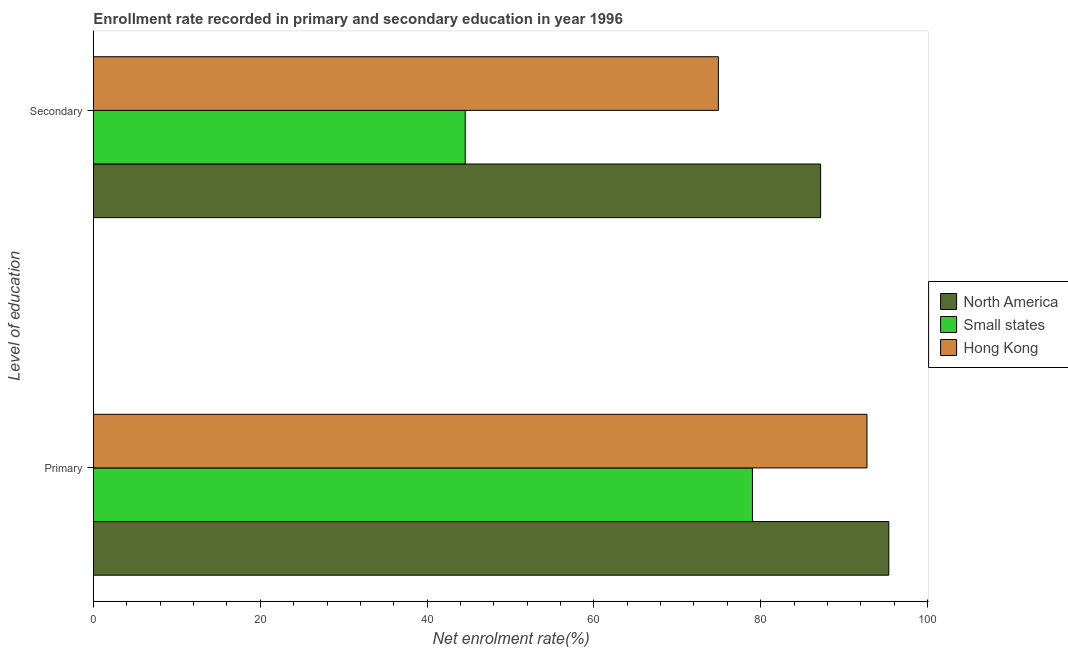How many groups of bars are there?
Your answer should be very brief. 2. Are the number of bars on each tick of the Y-axis equal?
Your response must be concise. Yes. How many bars are there on the 1st tick from the top?
Ensure brevity in your answer.  3. How many bars are there on the 2nd tick from the bottom?
Keep it short and to the point. 3. What is the label of the 1st group of bars from the top?
Keep it short and to the point. Secondary. What is the enrollment rate in secondary education in Hong Kong?
Your answer should be compact. 74.93. Across all countries, what is the maximum enrollment rate in primary education?
Your response must be concise. 95.36. Across all countries, what is the minimum enrollment rate in primary education?
Your response must be concise. 79.01. In which country was the enrollment rate in primary education minimum?
Keep it short and to the point. Small states. What is the total enrollment rate in secondary education in the graph?
Your response must be concise. 206.69. What is the difference between the enrollment rate in secondary education in Hong Kong and that in Small states?
Provide a short and direct response. 30.35. What is the difference between the enrollment rate in secondary education in Small states and the enrollment rate in primary education in North America?
Keep it short and to the point. -50.79. What is the average enrollment rate in primary education per country?
Offer a terse response. 89.04. What is the difference between the enrollment rate in secondary education and enrollment rate in primary education in Hong Kong?
Make the answer very short. -17.82. In how many countries, is the enrollment rate in primary education greater than 48 %?
Give a very brief answer. 3. What is the ratio of the enrollment rate in secondary education in Hong Kong to that in North America?
Keep it short and to the point. 0.86. In how many countries, is the enrollment rate in secondary education greater than the average enrollment rate in secondary education taken over all countries?
Ensure brevity in your answer.  2. What does the 2nd bar from the top in Secondary represents?
Make the answer very short. Small states. What does the 3rd bar from the bottom in Primary represents?
Your response must be concise. Hong Kong. How many bars are there?
Your answer should be very brief. 6. Are all the bars in the graph horizontal?
Ensure brevity in your answer.  Yes. What is the difference between two consecutive major ticks on the X-axis?
Ensure brevity in your answer.  20. Are the values on the major ticks of X-axis written in scientific E-notation?
Make the answer very short. No. Where does the legend appear in the graph?
Your response must be concise. Center right. What is the title of the graph?
Give a very brief answer. Enrollment rate recorded in primary and secondary education in year 1996. Does "Dominican Republic" appear as one of the legend labels in the graph?
Your answer should be compact. No. What is the label or title of the X-axis?
Provide a succinct answer. Net enrolment rate(%). What is the label or title of the Y-axis?
Your answer should be very brief. Level of education. What is the Net enrolment rate(%) of North America in Primary?
Provide a short and direct response. 95.36. What is the Net enrolment rate(%) in Small states in Primary?
Make the answer very short. 79.01. What is the Net enrolment rate(%) in Hong Kong in Primary?
Offer a terse response. 92.74. What is the Net enrolment rate(%) in North America in Secondary?
Ensure brevity in your answer.  87.19. What is the Net enrolment rate(%) of Small states in Secondary?
Offer a terse response. 44.57. What is the Net enrolment rate(%) of Hong Kong in Secondary?
Offer a terse response. 74.93. Across all Level of education, what is the maximum Net enrolment rate(%) of North America?
Your answer should be compact. 95.36. Across all Level of education, what is the maximum Net enrolment rate(%) in Small states?
Your answer should be very brief. 79.01. Across all Level of education, what is the maximum Net enrolment rate(%) of Hong Kong?
Ensure brevity in your answer.  92.74. Across all Level of education, what is the minimum Net enrolment rate(%) in North America?
Offer a very short reply. 87.19. Across all Level of education, what is the minimum Net enrolment rate(%) of Small states?
Your answer should be compact. 44.57. Across all Level of education, what is the minimum Net enrolment rate(%) of Hong Kong?
Your answer should be compact. 74.93. What is the total Net enrolment rate(%) in North America in the graph?
Offer a terse response. 182.55. What is the total Net enrolment rate(%) in Small states in the graph?
Ensure brevity in your answer.  123.58. What is the total Net enrolment rate(%) of Hong Kong in the graph?
Keep it short and to the point. 167.67. What is the difference between the Net enrolment rate(%) of North America in Primary and that in Secondary?
Your answer should be compact. 8.18. What is the difference between the Net enrolment rate(%) in Small states in Primary and that in Secondary?
Ensure brevity in your answer.  34.44. What is the difference between the Net enrolment rate(%) of Hong Kong in Primary and that in Secondary?
Provide a short and direct response. 17.82. What is the difference between the Net enrolment rate(%) of North America in Primary and the Net enrolment rate(%) of Small states in Secondary?
Provide a succinct answer. 50.79. What is the difference between the Net enrolment rate(%) of North America in Primary and the Net enrolment rate(%) of Hong Kong in Secondary?
Offer a terse response. 20.44. What is the difference between the Net enrolment rate(%) of Small states in Primary and the Net enrolment rate(%) of Hong Kong in Secondary?
Provide a succinct answer. 4.09. What is the average Net enrolment rate(%) of North America per Level of education?
Make the answer very short. 91.27. What is the average Net enrolment rate(%) in Small states per Level of education?
Make the answer very short. 61.79. What is the average Net enrolment rate(%) of Hong Kong per Level of education?
Give a very brief answer. 83.83. What is the difference between the Net enrolment rate(%) in North America and Net enrolment rate(%) in Small states in Primary?
Your response must be concise. 16.35. What is the difference between the Net enrolment rate(%) in North America and Net enrolment rate(%) in Hong Kong in Primary?
Your answer should be very brief. 2.62. What is the difference between the Net enrolment rate(%) of Small states and Net enrolment rate(%) of Hong Kong in Primary?
Provide a succinct answer. -13.73. What is the difference between the Net enrolment rate(%) of North America and Net enrolment rate(%) of Small states in Secondary?
Keep it short and to the point. 42.61. What is the difference between the Net enrolment rate(%) in North America and Net enrolment rate(%) in Hong Kong in Secondary?
Offer a terse response. 12.26. What is the difference between the Net enrolment rate(%) in Small states and Net enrolment rate(%) in Hong Kong in Secondary?
Ensure brevity in your answer.  -30.35. What is the ratio of the Net enrolment rate(%) in North America in Primary to that in Secondary?
Give a very brief answer. 1.09. What is the ratio of the Net enrolment rate(%) of Small states in Primary to that in Secondary?
Your response must be concise. 1.77. What is the ratio of the Net enrolment rate(%) of Hong Kong in Primary to that in Secondary?
Give a very brief answer. 1.24. What is the difference between the highest and the second highest Net enrolment rate(%) in North America?
Your answer should be compact. 8.18. What is the difference between the highest and the second highest Net enrolment rate(%) of Small states?
Offer a very short reply. 34.44. What is the difference between the highest and the second highest Net enrolment rate(%) of Hong Kong?
Offer a very short reply. 17.82. What is the difference between the highest and the lowest Net enrolment rate(%) of North America?
Ensure brevity in your answer.  8.18. What is the difference between the highest and the lowest Net enrolment rate(%) in Small states?
Offer a very short reply. 34.44. What is the difference between the highest and the lowest Net enrolment rate(%) in Hong Kong?
Make the answer very short. 17.82. 